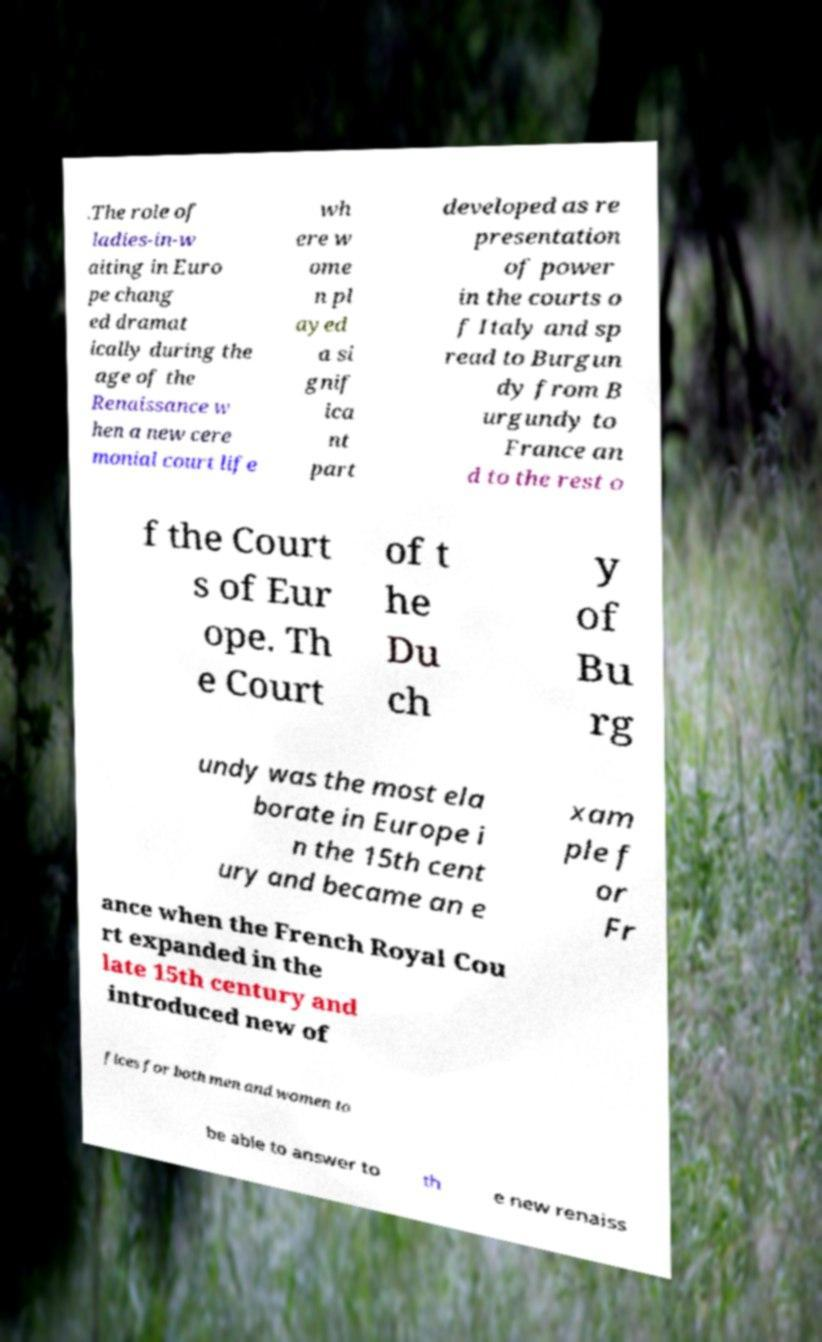Please identify and transcribe the text found in this image. .The role of ladies-in-w aiting in Euro pe chang ed dramat ically during the age of the Renaissance w hen a new cere monial court life wh ere w ome n pl ayed a si gnif ica nt part developed as re presentation of power in the courts o f Italy and sp read to Burgun dy from B urgundy to France an d to the rest o f the Court s of Eur ope. Th e Court of t he Du ch y of Bu rg undy was the most ela borate in Europe i n the 15th cent ury and became an e xam ple f or Fr ance when the French Royal Cou rt expanded in the late 15th century and introduced new of fices for both men and women to be able to answer to th e new renaiss 